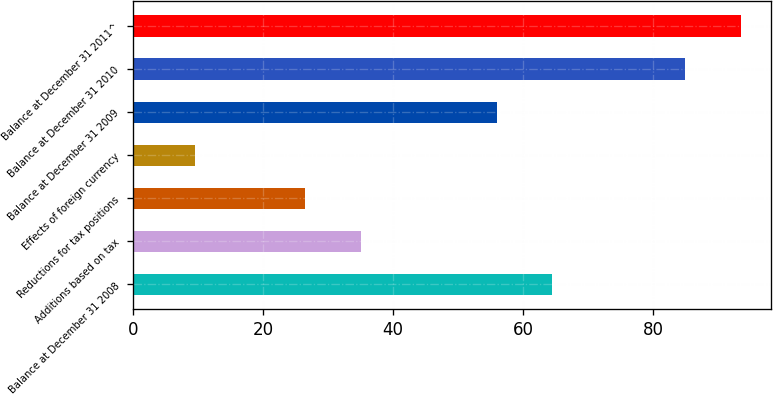Convert chart. <chart><loc_0><loc_0><loc_500><loc_500><bar_chart><fcel>Balance at December 31 2008<fcel>Additions based on tax<fcel>Reductions for tax positions<fcel>Effects of foreign currency<fcel>Balance at December 31 2009<fcel>Balance at December 31 2010<fcel>Balance at December 31 2011^<nl><fcel>64.5<fcel>35<fcel>26.5<fcel>9.5<fcel>56<fcel>85<fcel>93.5<nl></chart> 